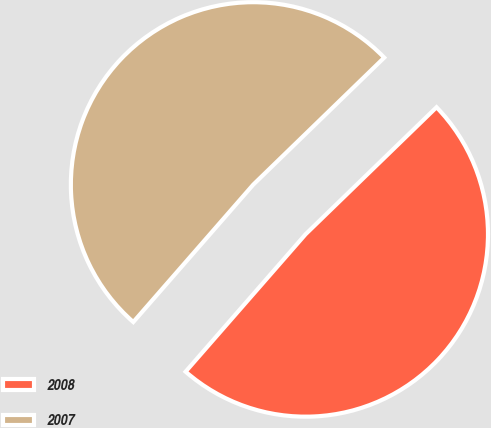Convert chart. <chart><loc_0><loc_0><loc_500><loc_500><pie_chart><fcel>2008<fcel>2007<nl><fcel>48.68%<fcel>51.32%<nl></chart> 